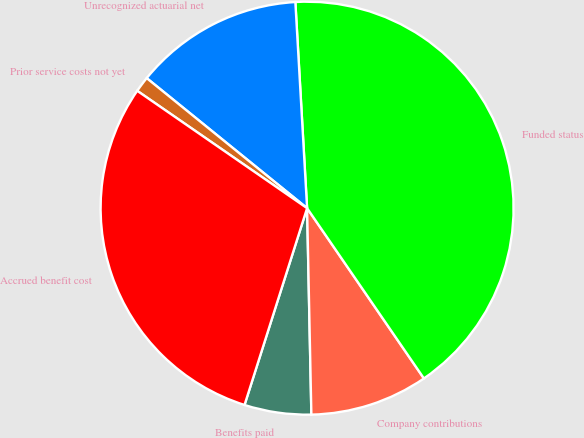<chart> <loc_0><loc_0><loc_500><loc_500><pie_chart><fcel>Benefits paid<fcel>Company contributions<fcel>Funded status<fcel>Unrecognized actuarial net<fcel>Prior service costs not yet<fcel>Accrued benefit cost<nl><fcel>5.23%<fcel>9.24%<fcel>41.33%<fcel>13.25%<fcel>1.22%<fcel>29.72%<nl></chart> 